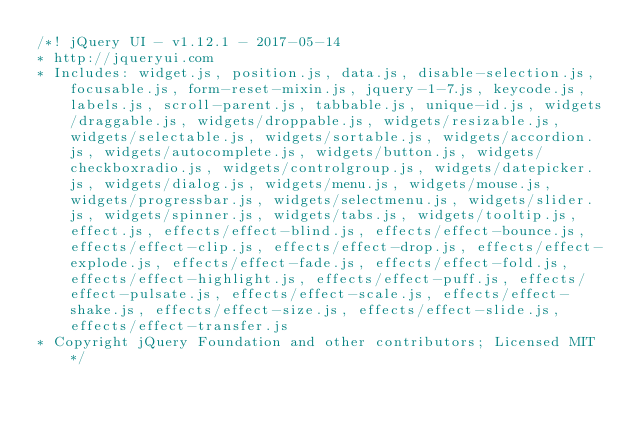<code> <loc_0><loc_0><loc_500><loc_500><_JavaScript_>/*! jQuery UI - v1.12.1 - 2017-05-14
* http://jqueryui.com
* Includes: widget.js, position.js, data.js, disable-selection.js, focusable.js, form-reset-mixin.js, jquery-1-7.js, keycode.js, labels.js, scroll-parent.js, tabbable.js, unique-id.js, widgets/draggable.js, widgets/droppable.js, widgets/resizable.js, widgets/selectable.js, widgets/sortable.js, widgets/accordion.js, widgets/autocomplete.js, widgets/button.js, widgets/checkboxradio.js, widgets/controlgroup.js, widgets/datepicker.js, widgets/dialog.js, widgets/menu.js, widgets/mouse.js, widgets/progressbar.js, widgets/selectmenu.js, widgets/slider.js, widgets/spinner.js, widgets/tabs.js, widgets/tooltip.js, effect.js, effects/effect-blind.js, effects/effect-bounce.js, effects/effect-clip.js, effects/effect-drop.js, effects/effect-explode.js, effects/effect-fade.js, effects/effect-fold.js, effects/effect-highlight.js, effects/effect-puff.js, effects/effect-pulsate.js, effects/effect-scale.js, effects/effect-shake.js, effects/effect-size.js, effects/effect-slide.js, effects/effect-transfer.js
* Copyright jQuery Foundation and other contributors; Licensed MIT */
</code> 